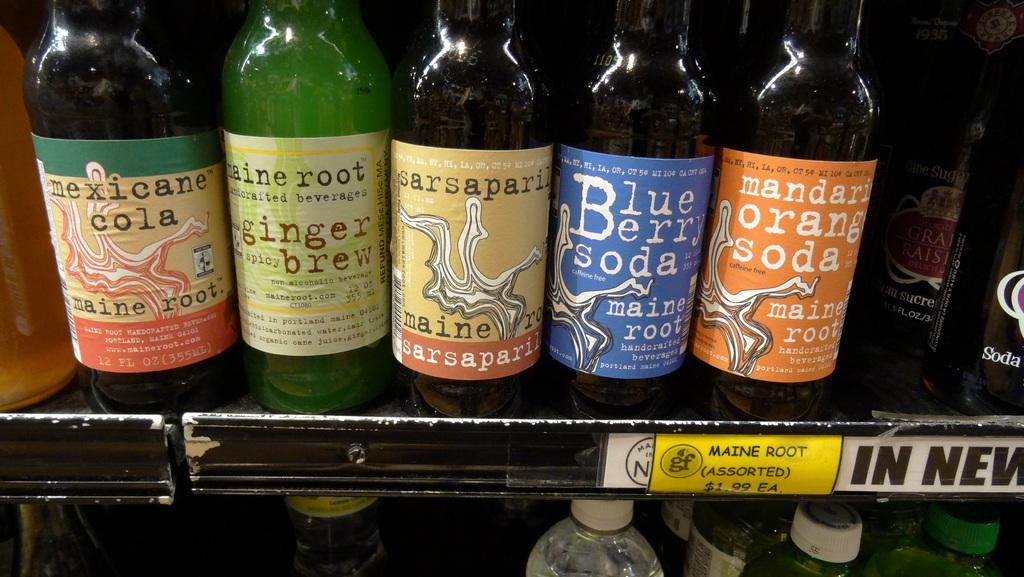<image>
Share a concise interpretation of the image provided. Several bottles of soda by Maine Root sit on a shelf. 